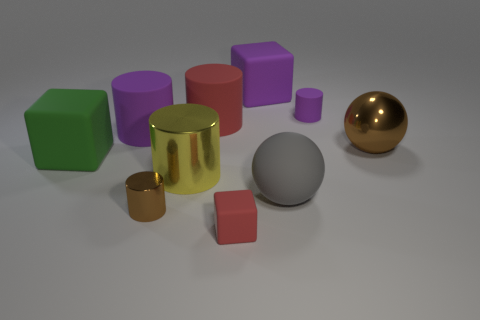Subtract 1 cubes. How many cubes are left? 2 Subtract all large blocks. How many blocks are left? 1 Subtract all yellow cylinders. How many cylinders are left? 4 Subtract all red cylinders. Subtract all cyan blocks. How many cylinders are left? 4 Subtract all cubes. How many objects are left? 7 Subtract all big brown shiny things. Subtract all purple rubber objects. How many objects are left? 6 Add 4 large shiny cylinders. How many large shiny cylinders are left? 5 Add 3 large purple blocks. How many large purple blocks exist? 4 Subtract 0 cyan cylinders. How many objects are left? 10 